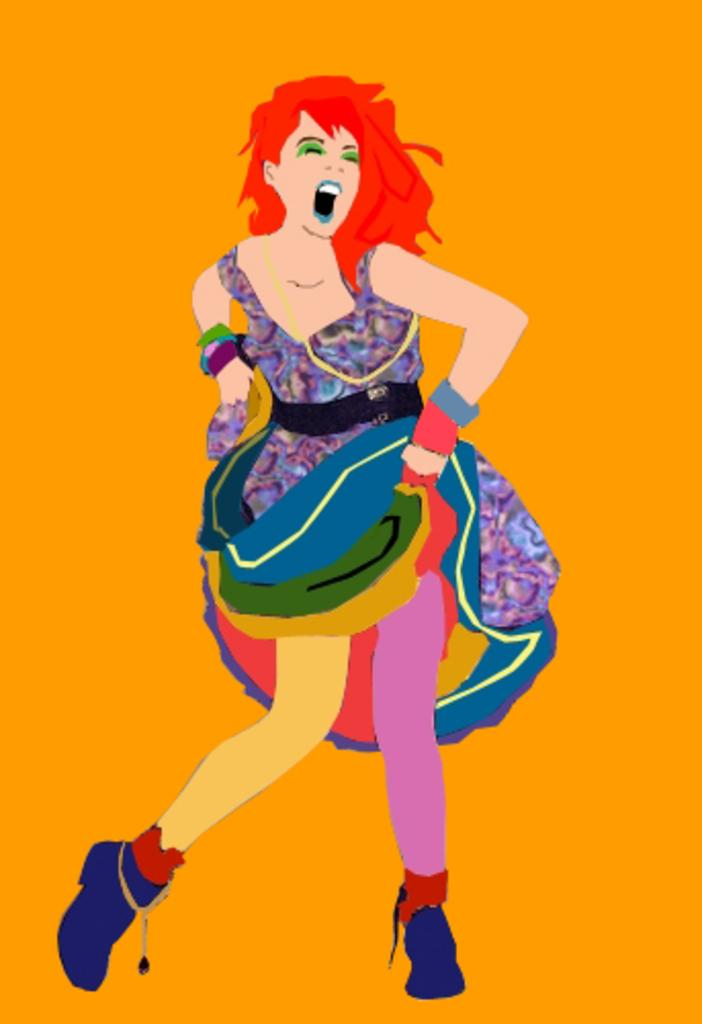What is the main subject of the painting in the image? There is a painting of a lady in the center of the image. What color can be seen in the background of the painting? There is an orange color in the background of the image. What type of creature is hiding in the lady's pocket in the image? There is no creature present in the image, and the lady in the painting does not have any pockets. 